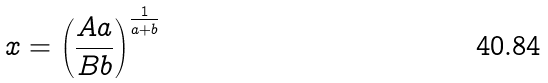<formula> <loc_0><loc_0><loc_500><loc_500>x = \left ( \frac { A a } { B b } \right ) ^ { \frac { 1 } { a + b } }</formula> 